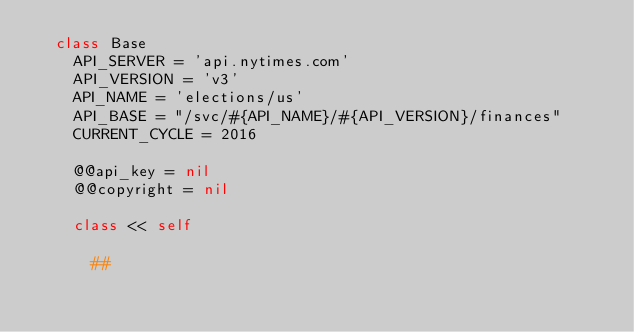<code> <loc_0><loc_0><loc_500><loc_500><_Ruby_>  class Base
    API_SERVER = 'api.nytimes.com'
    API_VERSION = 'v3'
    API_NAME = 'elections/us'
    API_BASE = "/svc/#{API_NAME}/#{API_VERSION}/finances"
    CURRENT_CYCLE = 2016

    @@api_key = nil
    @@copyright = nil

    class << self

      ##</code> 